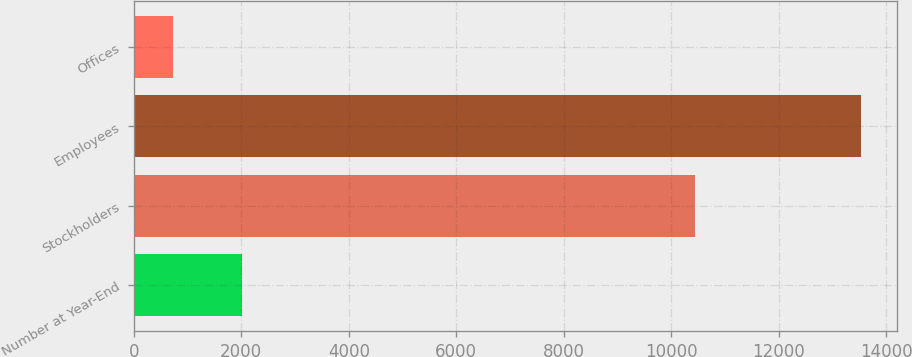Convert chart to OTSL. <chart><loc_0><loc_0><loc_500><loc_500><bar_chart><fcel>Number at Year-End<fcel>Stockholders<fcel>Employees<fcel>Offices<nl><fcel>2005<fcel>10437<fcel>13525<fcel>724<nl></chart> 